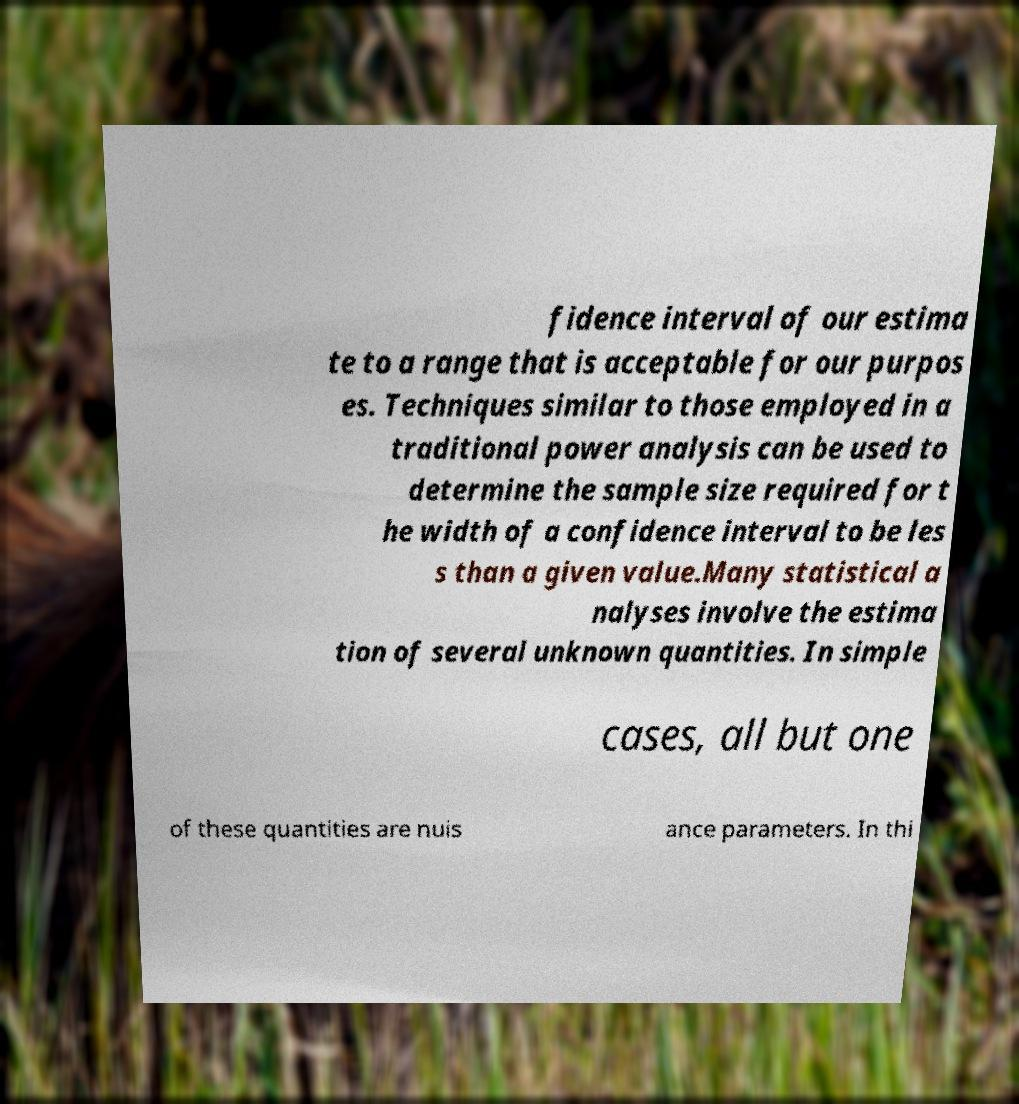Could you extract and type out the text from this image? fidence interval of our estima te to a range that is acceptable for our purpos es. Techniques similar to those employed in a traditional power analysis can be used to determine the sample size required for t he width of a confidence interval to be les s than a given value.Many statistical a nalyses involve the estima tion of several unknown quantities. In simple cases, all but one of these quantities are nuis ance parameters. In thi 